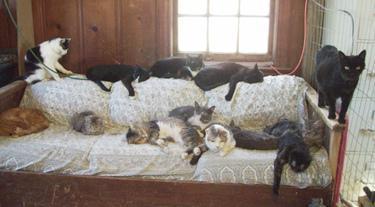How many red cats?
Give a very brief answer. 1. How many window panes?
Give a very brief answer. 6. How many cats?
Give a very brief answer. 14. How many cats are here?
Give a very brief answer. 13. 